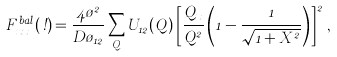<formula> <loc_0><loc_0><loc_500><loc_500>F _ { x x } ^ { b a l } ( \omega ) = \frac { 4 \tau ^ { 2 } } { D \tau _ { 1 2 } } \sum _ { Q } U _ { 1 2 } ( Q ) \left [ \frac { Q _ { x } } { Q ^ { 2 } } \left ( 1 - \frac { 1 } { \sqrt { 1 + X ^ { 2 } } } \right ) \right ] ^ { 2 } \, ,</formula> 